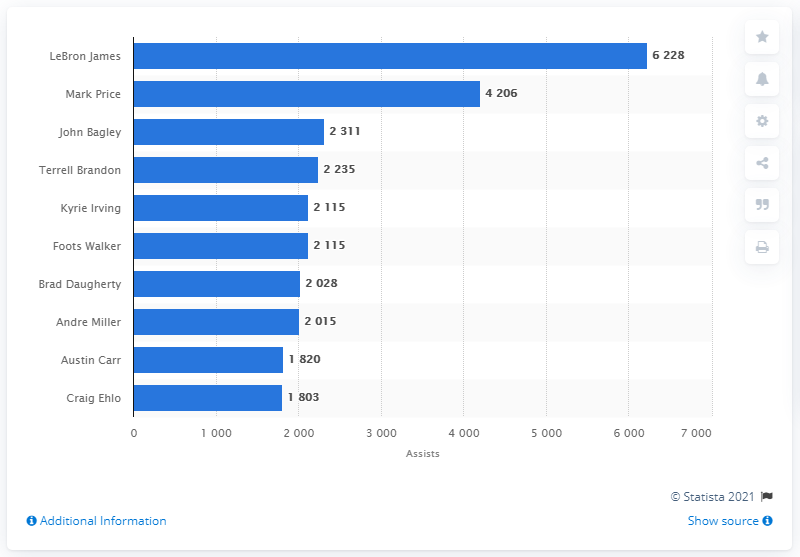List a handful of essential elements in this visual. The career assist leader of the Cleveland Cavaliers is LeBron James. 